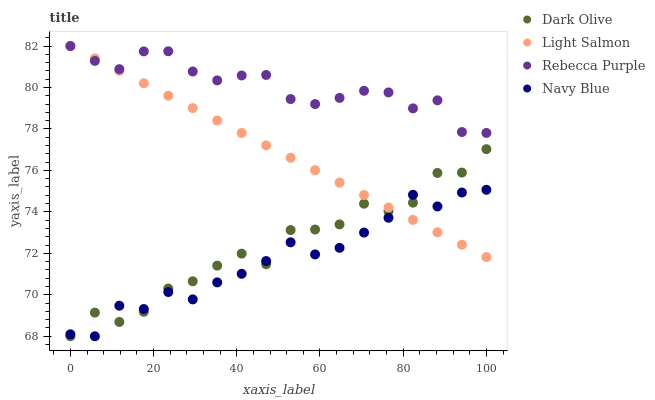Does Navy Blue have the minimum area under the curve?
Answer yes or no. Yes. Does Rebecca Purple have the maximum area under the curve?
Answer yes or no. Yes. Does Light Salmon have the minimum area under the curve?
Answer yes or no. No. Does Light Salmon have the maximum area under the curve?
Answer yes or no. No. Is Light Salmon the smoothest?
Answer yes or no. Yes. Is Dark Olive the roughest?
Answer yes or no. Yes. Is Dark Olive the smoothest?
Answer yes or no. No. Is Light Salmon the roughest?
Answer yes or no. No. Does Navy Blue have the lowest value?
Answer yes or no. Yes. Does Light Salmon have the lowest value?
Answer yes or no. No. Does Rebecca Purple have the highest value?
Answer yes or no. Yes. Does Dark Olive have the highest value?
Answer yes or no. No. Is Navy Blue less than Rebecca Purple?
Answer yes or no. Yes. Is Rebecca Purple greater than Navy Blue?
Answer yes or no. Yes. Does Navy Blue intersect Light Salmon?
Answer yes or no. Yes. Is Navy Blue less than Light Salmon?
Answer yes or no. No. Is Navy Blue greater than Light Salmon?
Answer yes or no. No. Does Navy Blue intersect Rebecca Purple?
Answer yes or no. No. 